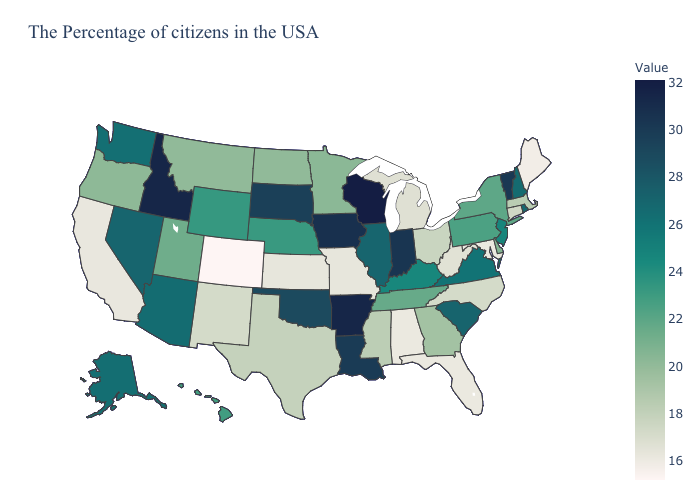Which states hav the highest value in the Northeast?
Give a very brief answer. Vermont. Does Nebraska have a lower value than Connecticut?
Be succinct. No. Which states have the lowest value in the Northeast?
Write a very short answer. Maine. 